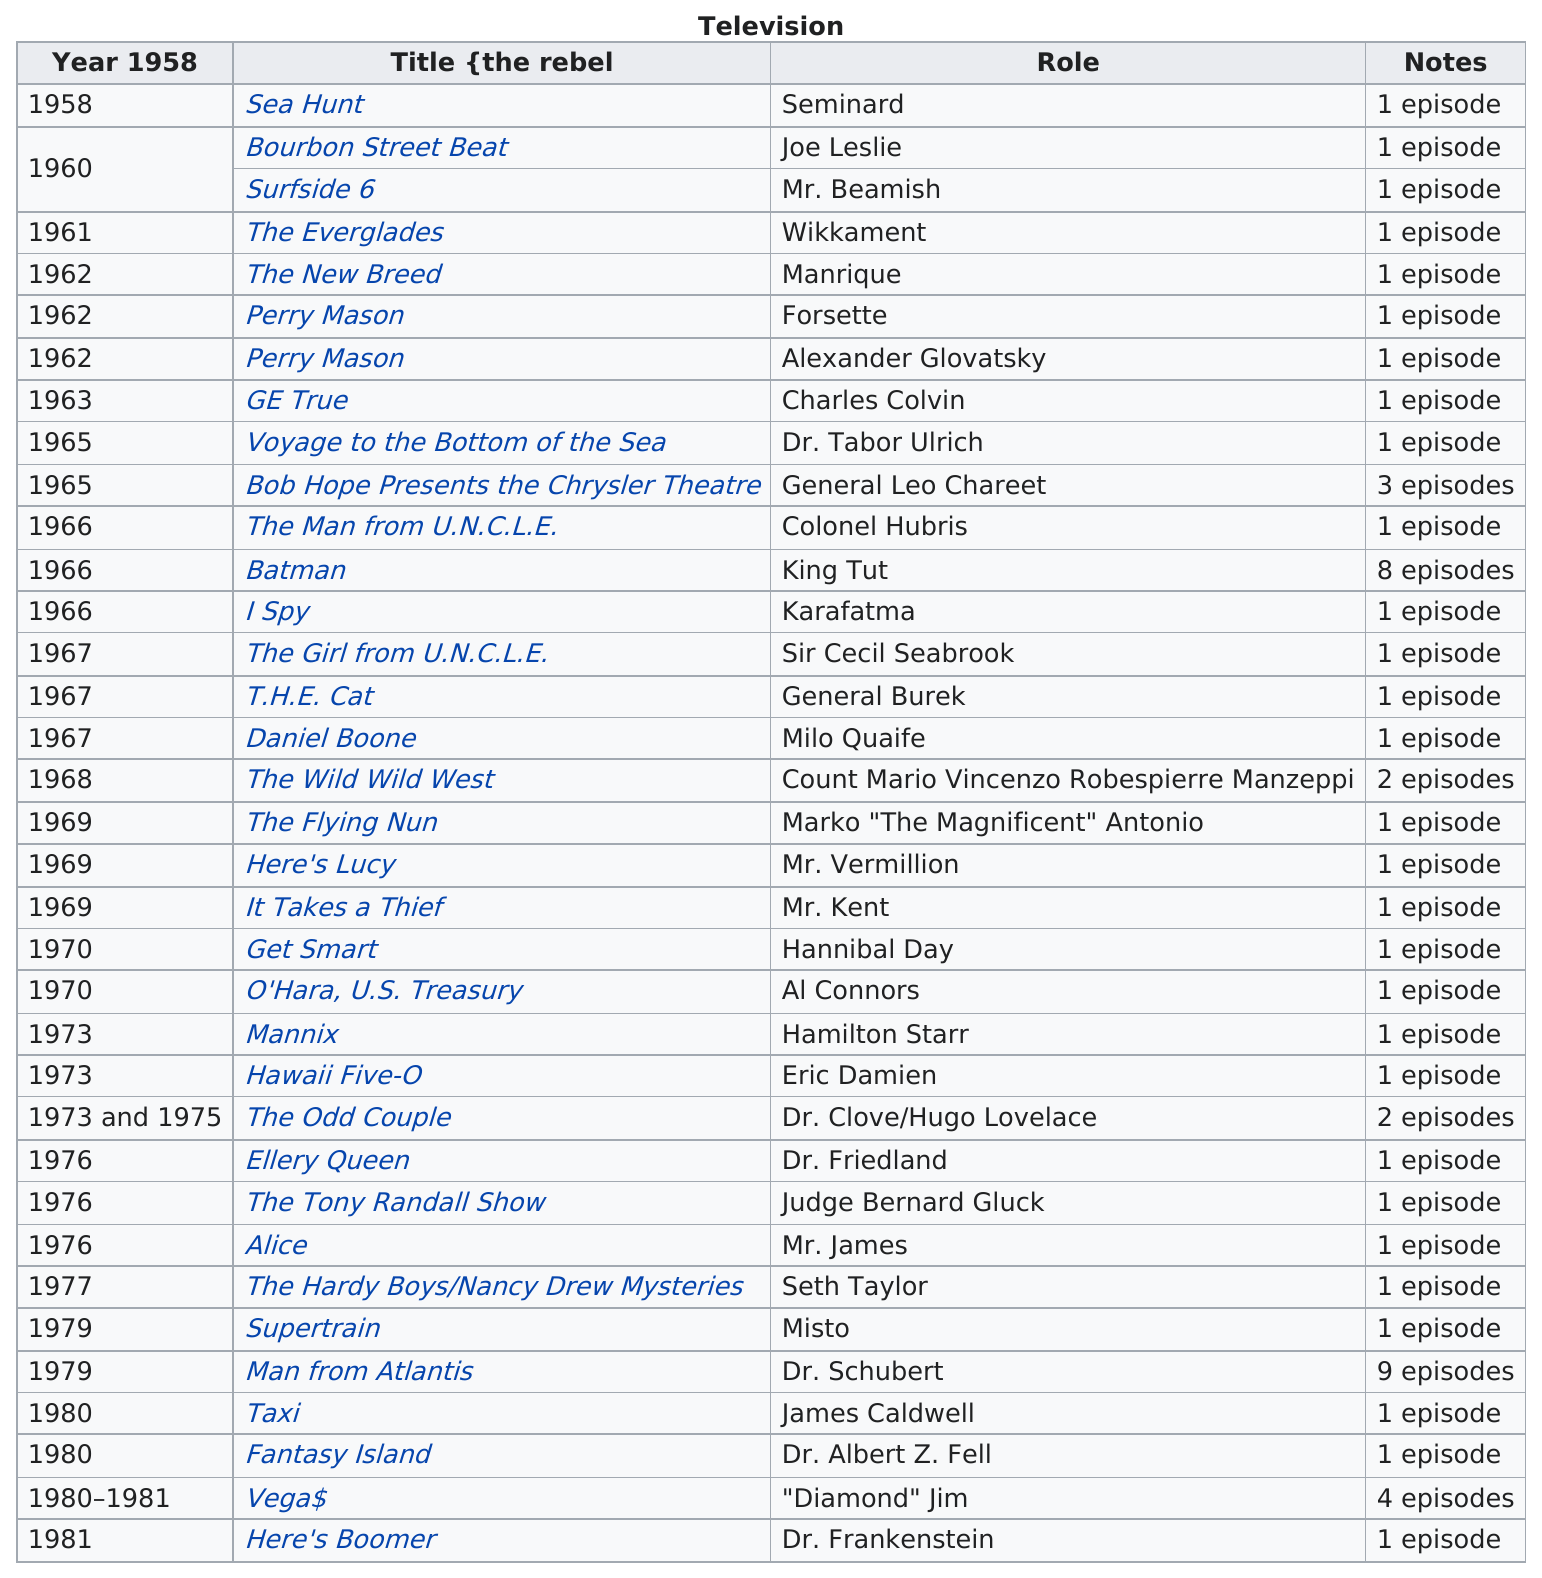Outline some significant characteristics in this image. In 1979, the year with the most episodes played in shows was Victor Buono played the role of Mr. Beamish in the television series Surfside 6. In 1979, the subject was most prominently featured in shows. 